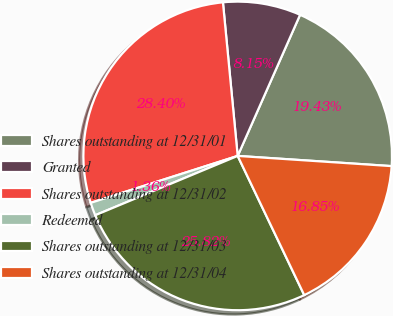<chart> <loc_0><loc_0><loc_500><loc_500><pie_chart><fcel>Shares outstanding at 12/31/01<fcel>Granted<fcel>Shares outstanding at 12/31/02<fcel>Redeemed<fcel>Shares outstanding at 12/31/03<fcel>Shares outstanding at 12/31/04<nl><fcel>19.43%<fcel>8.15%<fcel>28.4%<fcel>1.36%<fcel>25.82%<fcel>16.85%<nl></chart> 